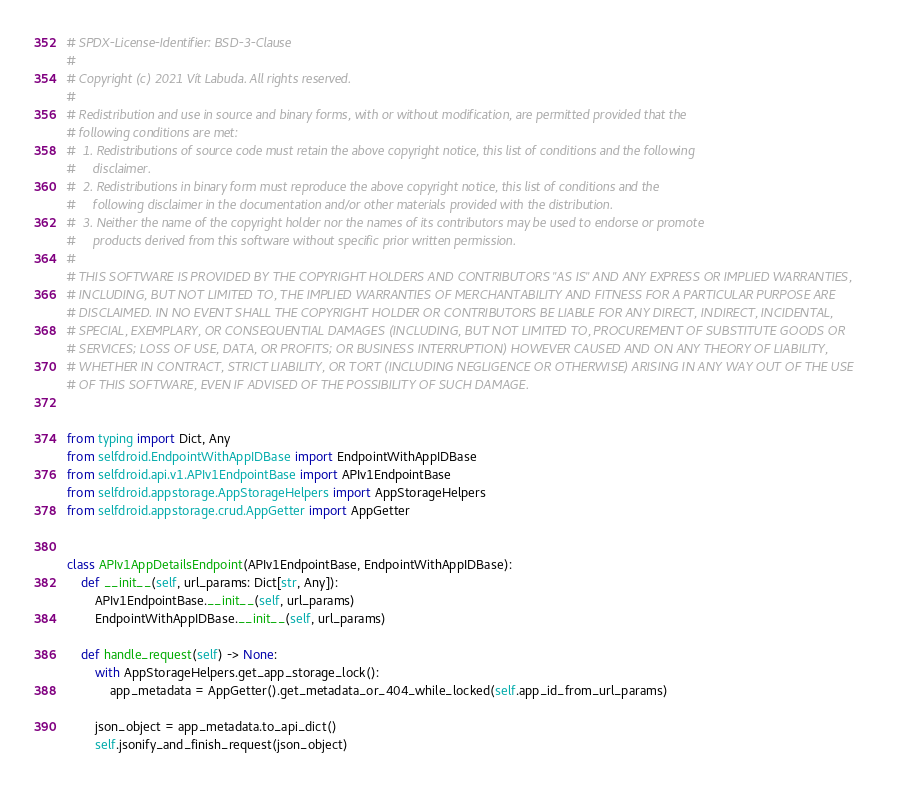<code> <loc_0><loc_0><loc_500><loc_500><_Python_># SPDX-License-Identifier: BSD-3-Clause
#
# Copyright (c) 2021 Vít Labuda. All rights reserved.
#
# Redistribution and use in source and binary forms, with or without modification, are permitted provided that the
# following conditions are met:
#  1. Redistributions of source code must retain the above copyright notice, this list of conditions and the following
#     disclaimer.
#  2. Redistributions in binary form must reproduce the above copyright notice, this list of conditions and the
#     following disclaimer in the documentation and/or other materials provided with the distribution.
#  3. Neither the name of the copyright holder nor the names of its contributors may be used to endorse or promote
#     products derived from this software without specific prior written permission.
#
# THIS SOFTWARE IS PROVIDED BY THE COPYRIGHT HOLDERS AND CONTRIBUTORS "AS IS" AND ANY EXPRESS OR IMPLIED WARRANTIES,
# INCLUDING, BUT NOT LIMITED TO, THE IMPLIED WARRANTIES OF MERCHANTABILITY AND FITNESS FOR A PARTICULAR PURPOSE ARE
# DISCLAIMED. IN NO EVENT SHALL THE COPYRIGHT HOLDER OR CONTRIBUTORS BE LIABLE FOR ANY DIRECT, INDIRECT, INCIDENTAL,
# SPECIAL, EXEMPLARY, OR CONSEQUENTIAL DAMAGES (INCLUDING, BUT NOT LIMITED TO, PROCUREMENT OF SUBSTITUTE GOODS OR
# SERVICES; LOSS OF USE, DATA, OR PROFITS; OR BUSINESS INTERRUPTION) HOWEVER CAUSED AND ON ANY THEORY OF LIABILITY,
# WHETHER IN CONTRACT, STRICT LIABILITY, OR TORT (INCLUDING NEGLIGENCE OR OTHERWISE) ARISING IN ANY WAY OUT OF THE USE
# OF THIS SOFTWARE, EVEN IF ADVISED OF THE POSSIBILITY OF SUCH DAMAGE.


from typing import Dict, Any
from selfdroid.EndpointWithAppIDBase import EndpointWithAppIDBase
from selfdroid.api.v1.APIv1EndpointBase import APIv1EndpointBase
from selfdroid.appstorage.AppStorageHelpers import AppStorageHelpers
from selfdroid.appstorage.crud.AppGetter import AppGetter


class APIv1AppDetailsEndpoint(APIv1EndpointBase, EndpointWithAppIDBase):
    def __init__(self, url_params: Dict[str, Any]):
        APIv1EndpointBase.__init__(self, url_params)
        EndpointWithAppIDBase.__init__(self, url_params)

    def handle_request(self) -> None:
        with AppStorageHelpers.get_app_storage_lock():
            app_metadata = AppGetter().get_metadata_or_404_while_locked(self.app_id_from_url_params)

        json_object = app_metadata.to_api_dict()
        self.jsonify_and_finish_request(json_object)
</code> 